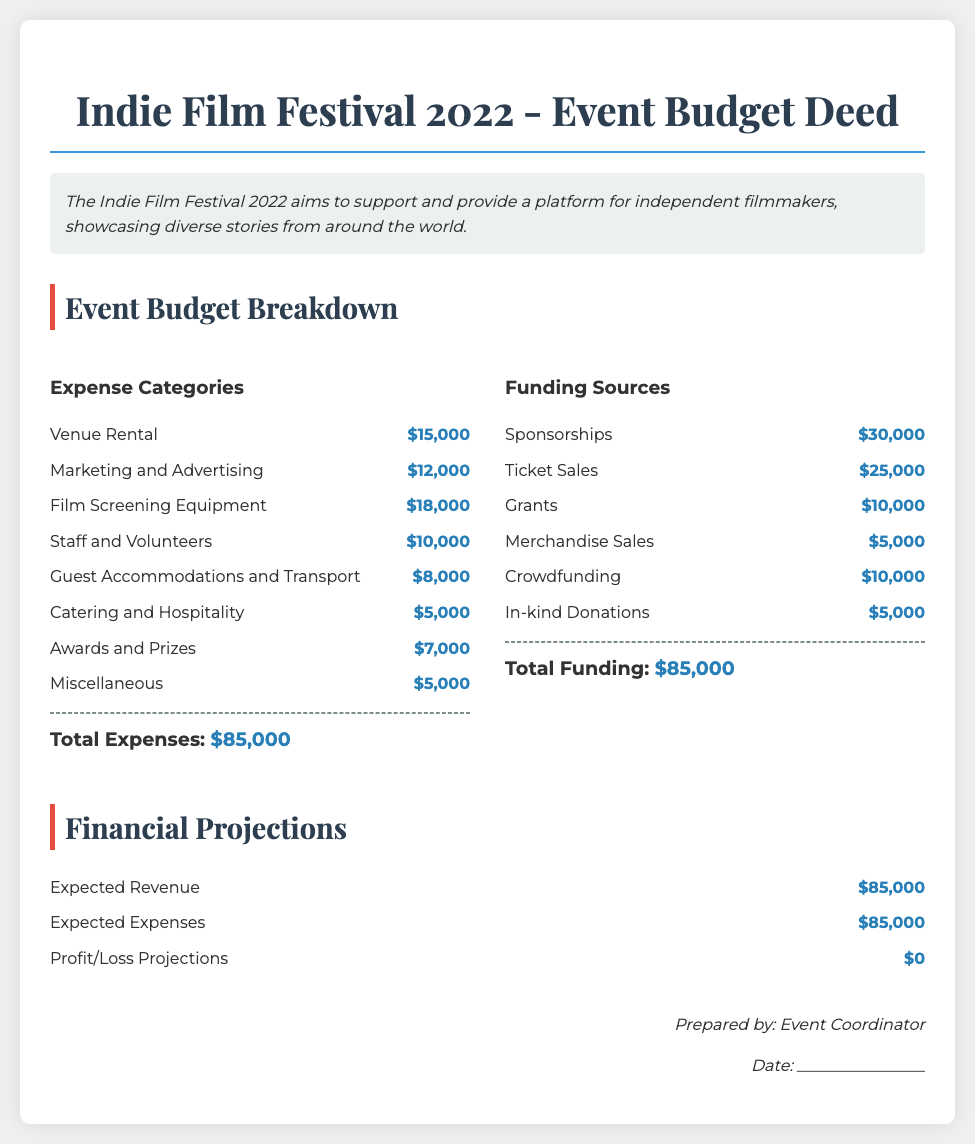What is the total amount allocated for Venue Rental? The total amount allocated for Venue Rental is specified in the budget breakdown section under Expense Categories, which is $15,000.
Answer: $15,000 How much is budgeted for Marketing and Advertising? The budget for Marketing and Advertising can be found in the Expense Categories section, listed as $12,000.
Answer: $12,000 What is the total amount of funding from Sponsorships? The total funding from Sponsorships is found under the Funding Sources section, which states $30,000.
Answer: $30,000 What are the total expected revenues? The total expected revenues are calculated in the Financial Projections section, which totals $85,000.
Answer: $85,000 How much is allocated for Awards and Prizes? The allocation for Awards and Prizes is detailed under Expense Categories, which shows $7,000.
Answer: $7,000 What is the overall expected profit or loss for the festival? The overall expected profit or loss is detailed in the Financial Projections section, which indicates $0.
Answer: $0 What is the sum of Ticket Sales? The sum of Ticket Sales is stated in the Funding Sources section as $25,000.
Answer: $25,000 How much is set aside for Guest Accommodations and Transport? The amount set aside for Guest Accommodations and Transport can be found in the Expense Categories, which lists it as $8,000.
Answer: $8,000 What date is the event budget prepared by? The document includes a placeholder for the date of preparation, indicated as ________________.
Answer: ________________ 